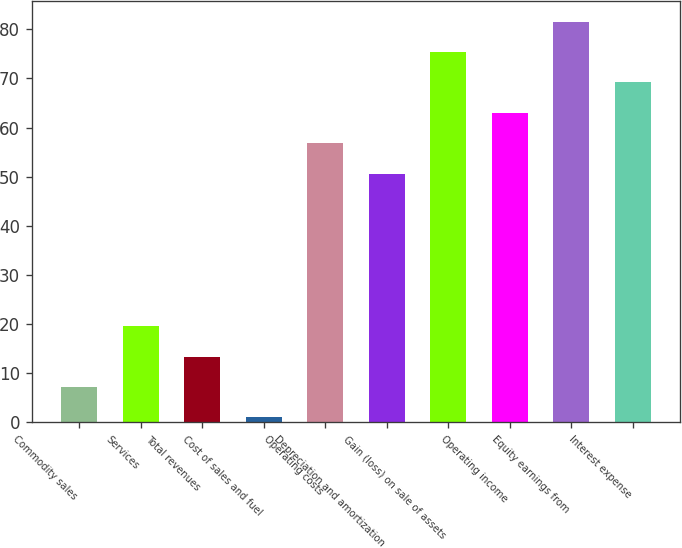Convert chart. <chart><loc_0><loc_0><loc_500><loc_500><bar_chart><fcel>Commodity sales<fcel>Services<fcel>Total revenues<fcel>Cost of sales and fuel<fcel>Operating costs<fcel>Depreciation and amortization<fcel>Gain (loss) on sale of assets<fcel>Operating income<fcel>Equity earnings from<fcel>Interest expense<nl><fcel>7.2<fcel>19.6<fcel>13.4<fcel>1<fcel>56.8<fcel>50.6<fcel>75.4<fcel>63<fcel>81.6<fcel>69.2<nl></chart> 